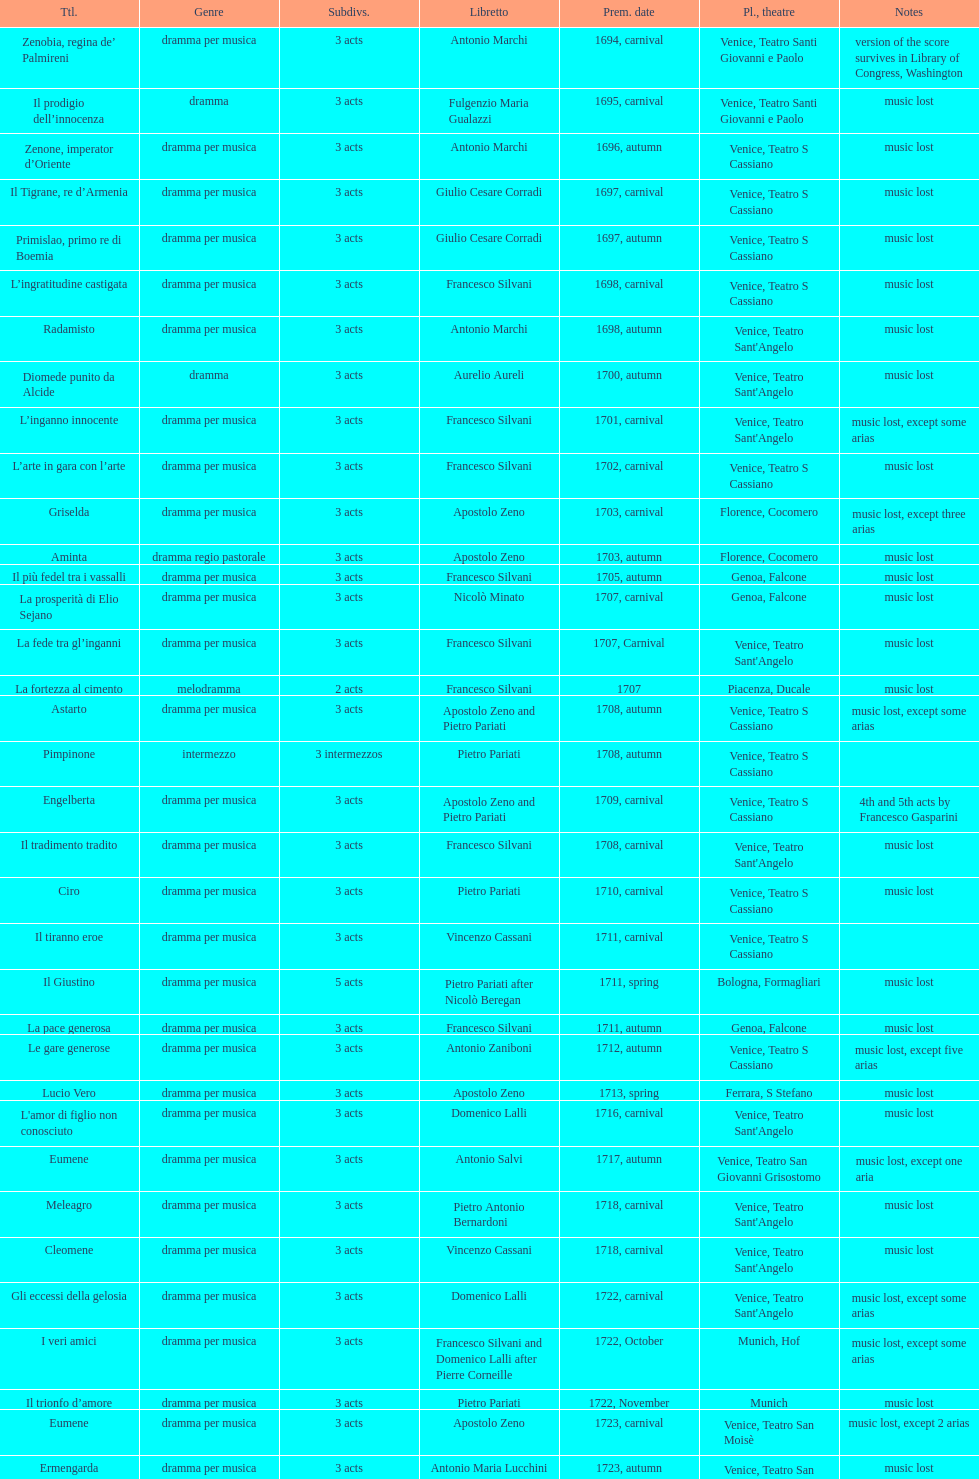How many operas on this list has at least 3 acts? 51. 